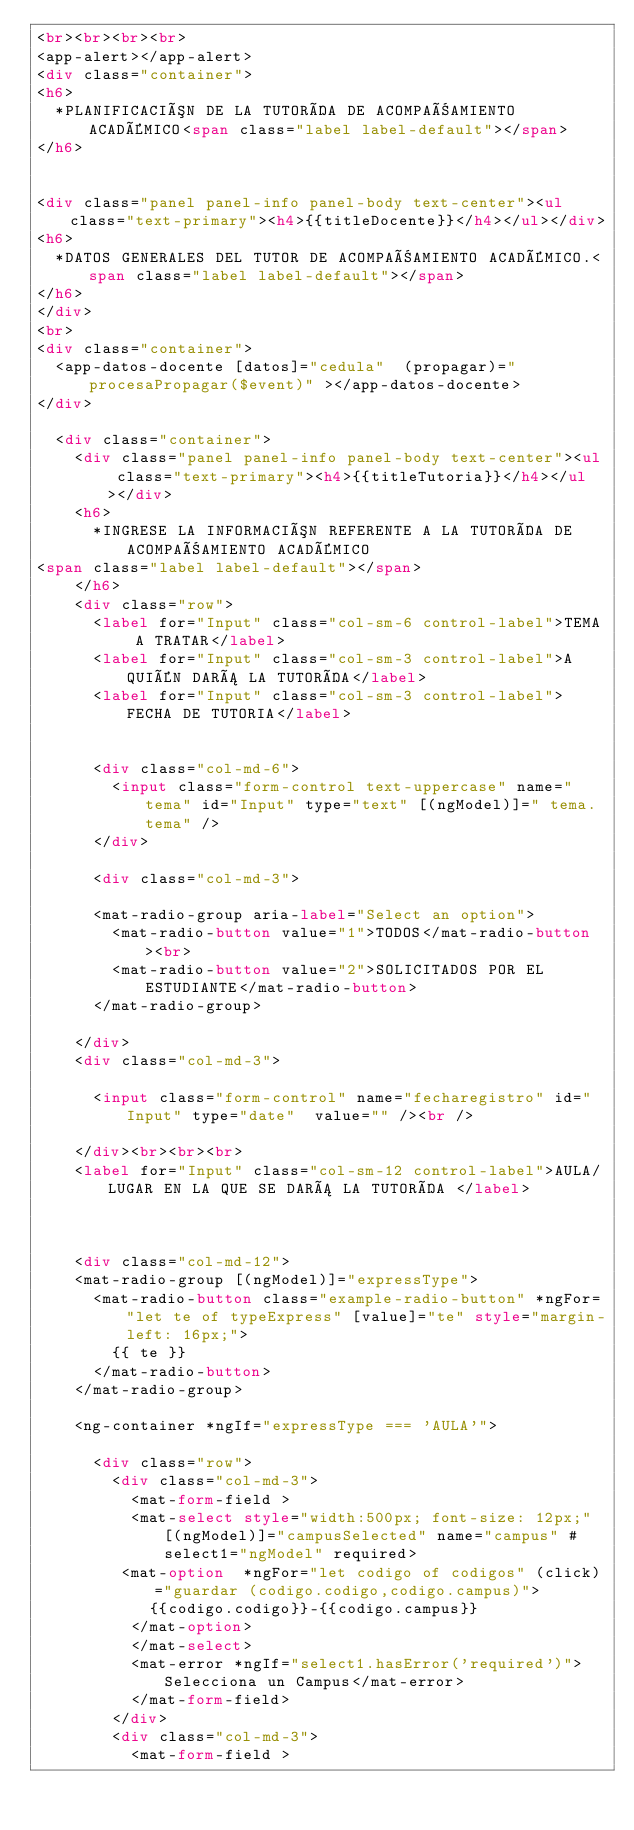Convert code to text. <code><loc_0><loc_0><loc_500><loc_500><_HTML_><br><br><br><br>
<app-alert></app-alert>
<div class="container">
<h6>
  *PLANIFICACIÓN DE LA TUTORÍA DE ACOMPAÑAMIENTO ACADÉMICO<span class="label label-default"></span>
</h6>


<div class="panel panel-info panel-body text-center"><ul class="text-primary"><h4>{{titleDocente}}</h4></ul></div>
<h6>
  *DATOS GENERALES DEL TUTOR DE ACOMPAÑAMIENTO ACADÉMICO.<span class="label label-default"></span>
</h6>
</div>
<br>
<div class="container">
  <app-datos-docente [datos]="cedula"  (propagar)="procesaPropagar($event)" ></app-datos-docente>
</div>
 
  <div class="container">
    <div class="panel panel-info panel-body text-center"><ul class="text-primary"><h4>{{titleTutoria}}</h4></ul></div>
    <h6>
      *INGRESE LA INFORMACIÓN REFERENTE A LA TUTORÍA DE ACOMPAÑAMIENTO ACADÉMICO
<span class="label label-default"></span>
    </h6>
    <div class="row">
      <label for="Input" class="col-sm-6 control-label">TEMA A TRATAR</label>
      <label for="Input" class="col-sm-3 control-label">A QUIÉN DARÁ LA TUTORÍA</label>
      <label for="Input" class="col-sm-3 control-label">FECHA DE TUTORIA</label>

  
      <div class="col-md-6">
        <input class="form-control text-uppercase" name="tema" id="Input" type="text" [(ngModel)]=" tema.tema" />
      </div>
  
      <div class="col-md-3">
       
      <mat-radio-group aria-label="Select an option">
        <mat-radio-button value="1">TODOS</mat-radio-button><br>
        <mat-radio-button value="2">SOLICITADOS POR EL ESTUDIANTE</mat-radio-button>
      </mat-radio-group>

    </div>
    <div class="col-md-3">
    
      <input class="form-control" name="fecharegistro" id="Input" type="date"  value="" /><br />
      
    </div><br><br><br>
    <label for="Input" class="col-sm-12 control-label">AULA/LUGAR EN LA QUE SE DARÁ LA TUTORÍA </label>
  
   

    <div class="col-md-12">
    <mat-radio-group [(ngModel)]="expressType">
      <mat-radio-button class="example-radio-button" *ngFor="let te of typeExpress" [value]="te" style="margin-left: 16px;">
        {{ te }}
      </mat-radio-button>
    </mat-radio-group>
    
    <ng-container *ngIf="expressType === 'AULA'">
      
      <div class="row">
        <div class="col-md-3">
          <mat-form-field > 
          <mat-select style="width:500px; font-size: 12px;" [(ngModel)]="campusSelected" name="campus" #select1="ngModel" required> 
         <mat-option  *ngFor="let codigo of codigos" (click)="guardar (codigo.codigo,codigo.campus)">
            {{codigo.codigo}}-{{codigo.campus}} 
          </mat-option>
          </mat-select>
          <mat-error *ngIf="select1.hasError('required')">Selecciona un Campus</mat-error>
          </mat-form-field>
        </div>
        <div class="col-md-3">
          <mat-form-field > </code> 